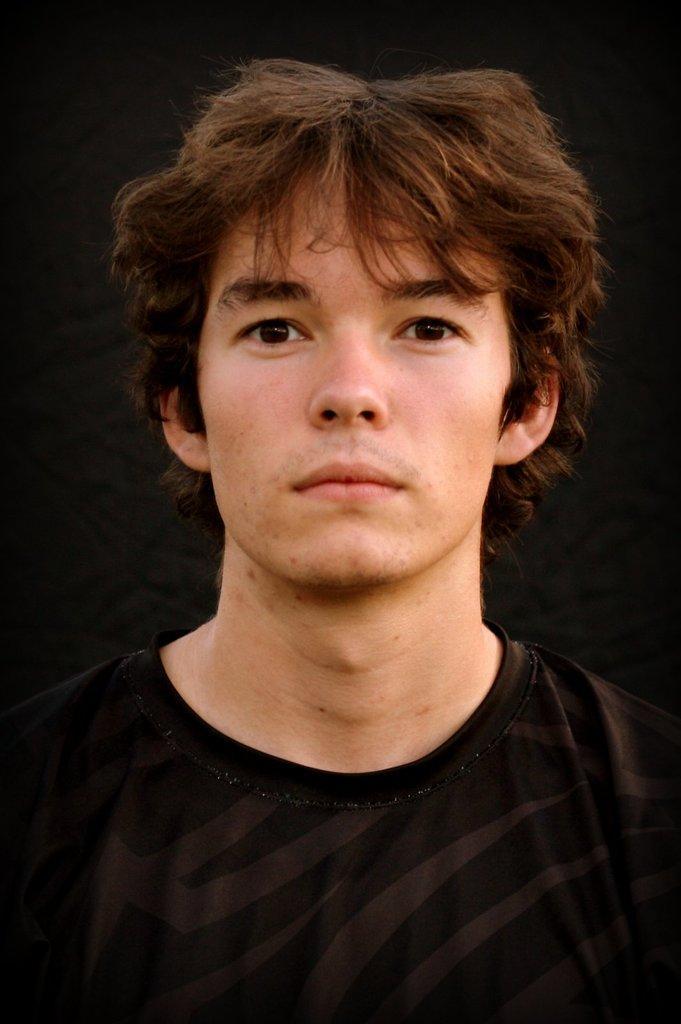Please provide a concise description of this image. In the picture I can see a man in the middle of the image and he is wearing a black color T-shirt. 